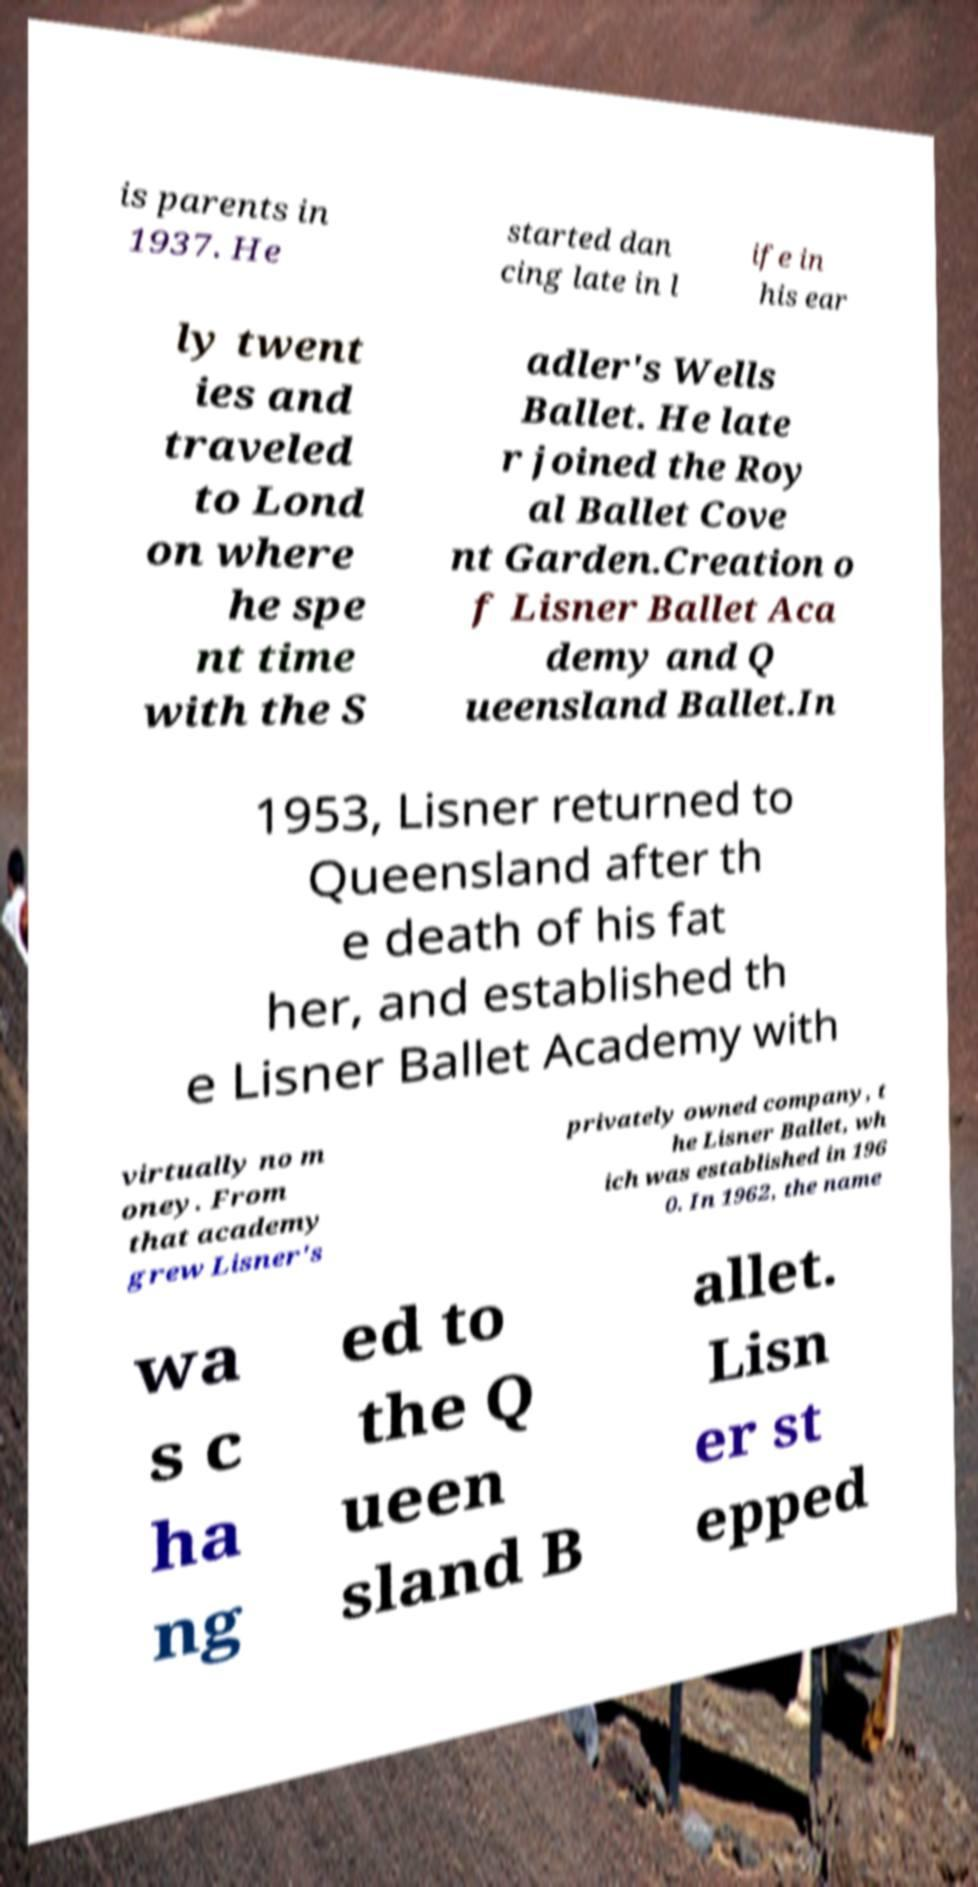Could you extract and type out the text from this image? is parents in 1937. He started dan cing late in l ife in his ear ly twent ies and traveled to Lond on where he spe nt time with the S adler's Wells Ballet. He late r joined the Roy al Ballet Cove nt Garden.Creation o f Lisner Ballet Aca demy and Q ueensland Ballet.In 1953, Lisner returned to Queensland after th e death of his fat her, and established th e Lisner Ballet Academy with virtually no m oney. From that academy grew Lisner's privately owned company, t he Lisner Ballet, wh ich was established in 196 0. In 1962, the name wa s c ha ng ed to the Q ueen sland B allet. Lisn er st epped 